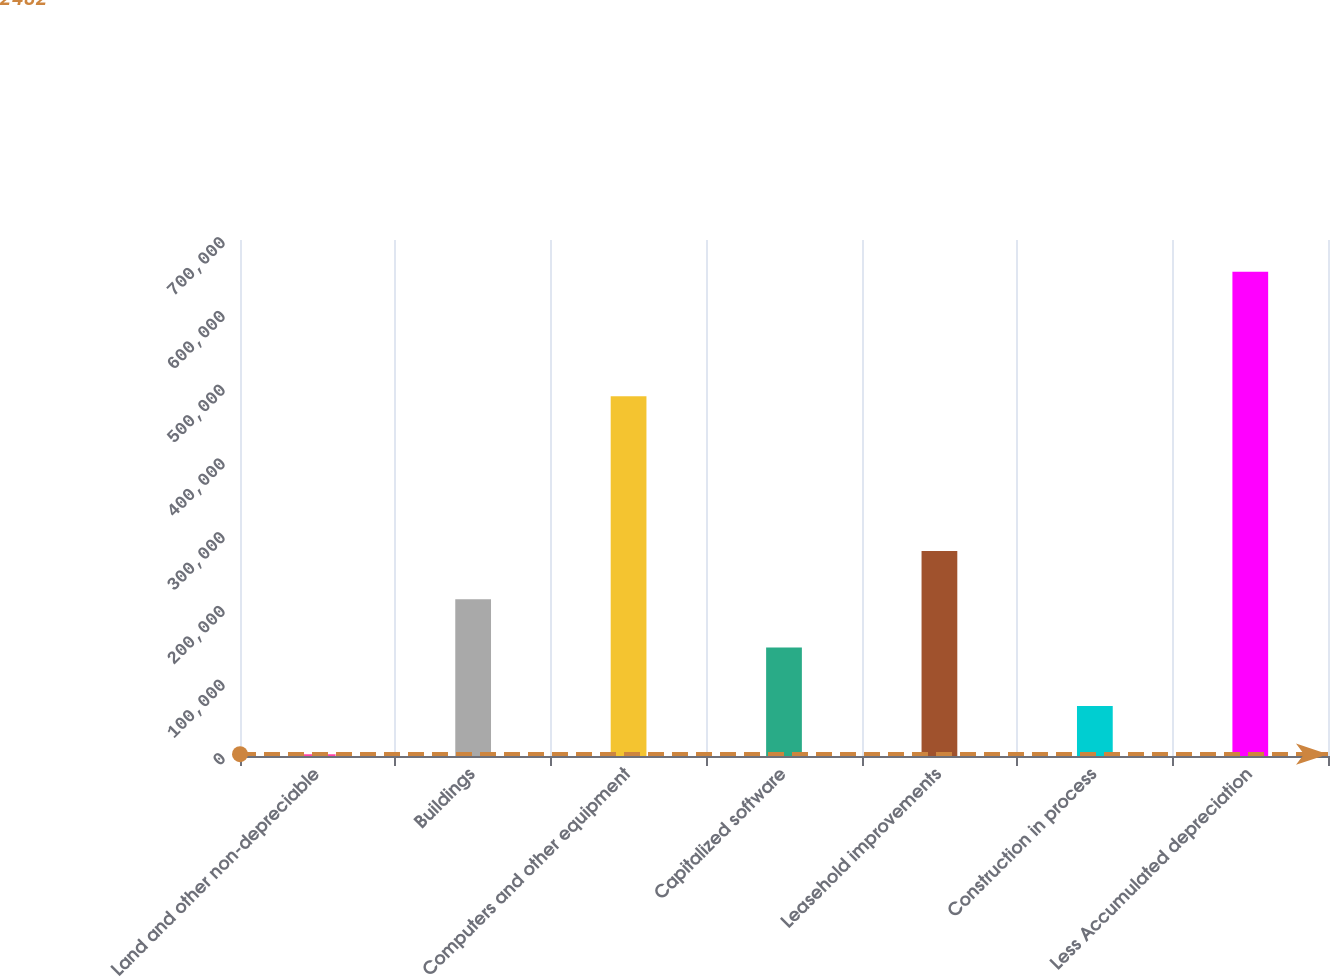<chart> <loc_0><loc_0><loc_500><loc_500><bar_chart><fcel>Land and other non-depreciable<fcel>Buildings<fcel>Computers and other equipment<fcel>Capitalized software<fcel>Leasehold improvements<fcel>Construction in process<fcel>Less Accumulated depreciation<nl><fcel>2482<fcel>212557<fcel>488160<fcel>147104<fcel>278009<fcel>67934.6<fcel>657008<nl></chart> 